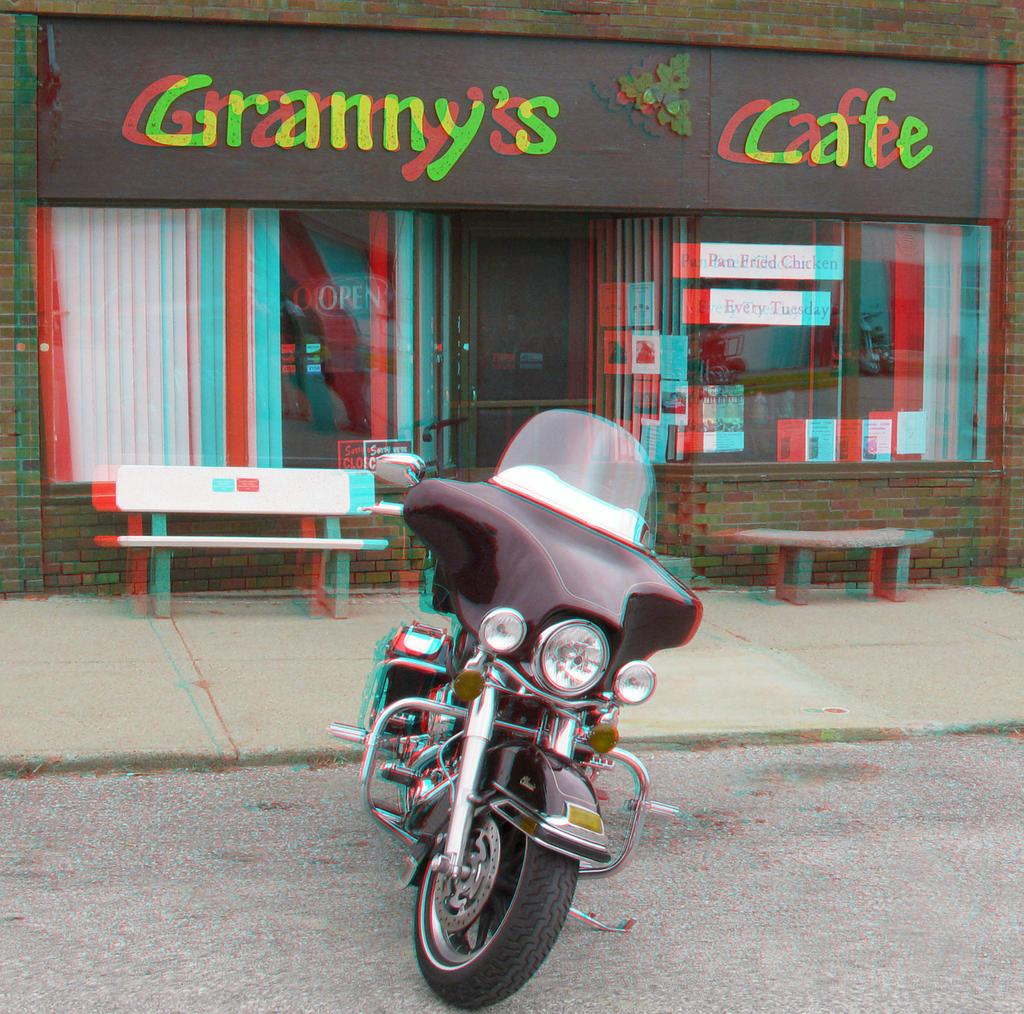What is the main object in the image? There is a bike in the image. What can be seen behind the bike? There are two benches behind the bike. What is located at the back side of the image? There is a building at the back side of the image. What type of scent can be detected coming from the bike in the image? There is no indication of a scent in the image, as it only features a bike, benches, and a building. 